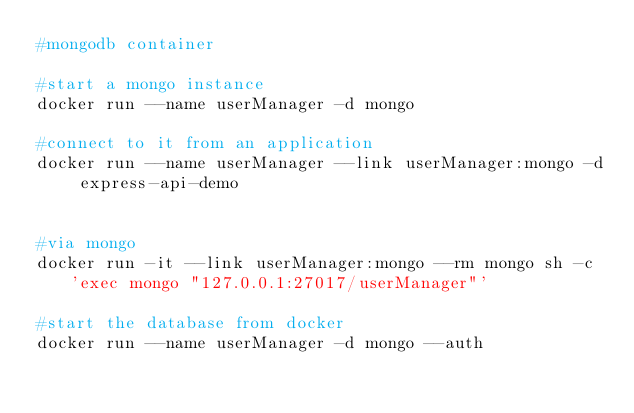<code> <loc_0><loc_0><loc_500><loc_500><_Dockerfile_>#mongodb container

#start a mongo instance
docker run --name userManager -d mongo

#connect to it from an application
docker run --name userManager --link userManager:mongo -d express-api-demo


#via mongo
docker run -it --link userManager:mongo --rm mongo sh -c 'exec mongo "127.0.0.1:27017/userManager"'

#start the database from docker
docker run --name userManager -d mongo --auth</code> 